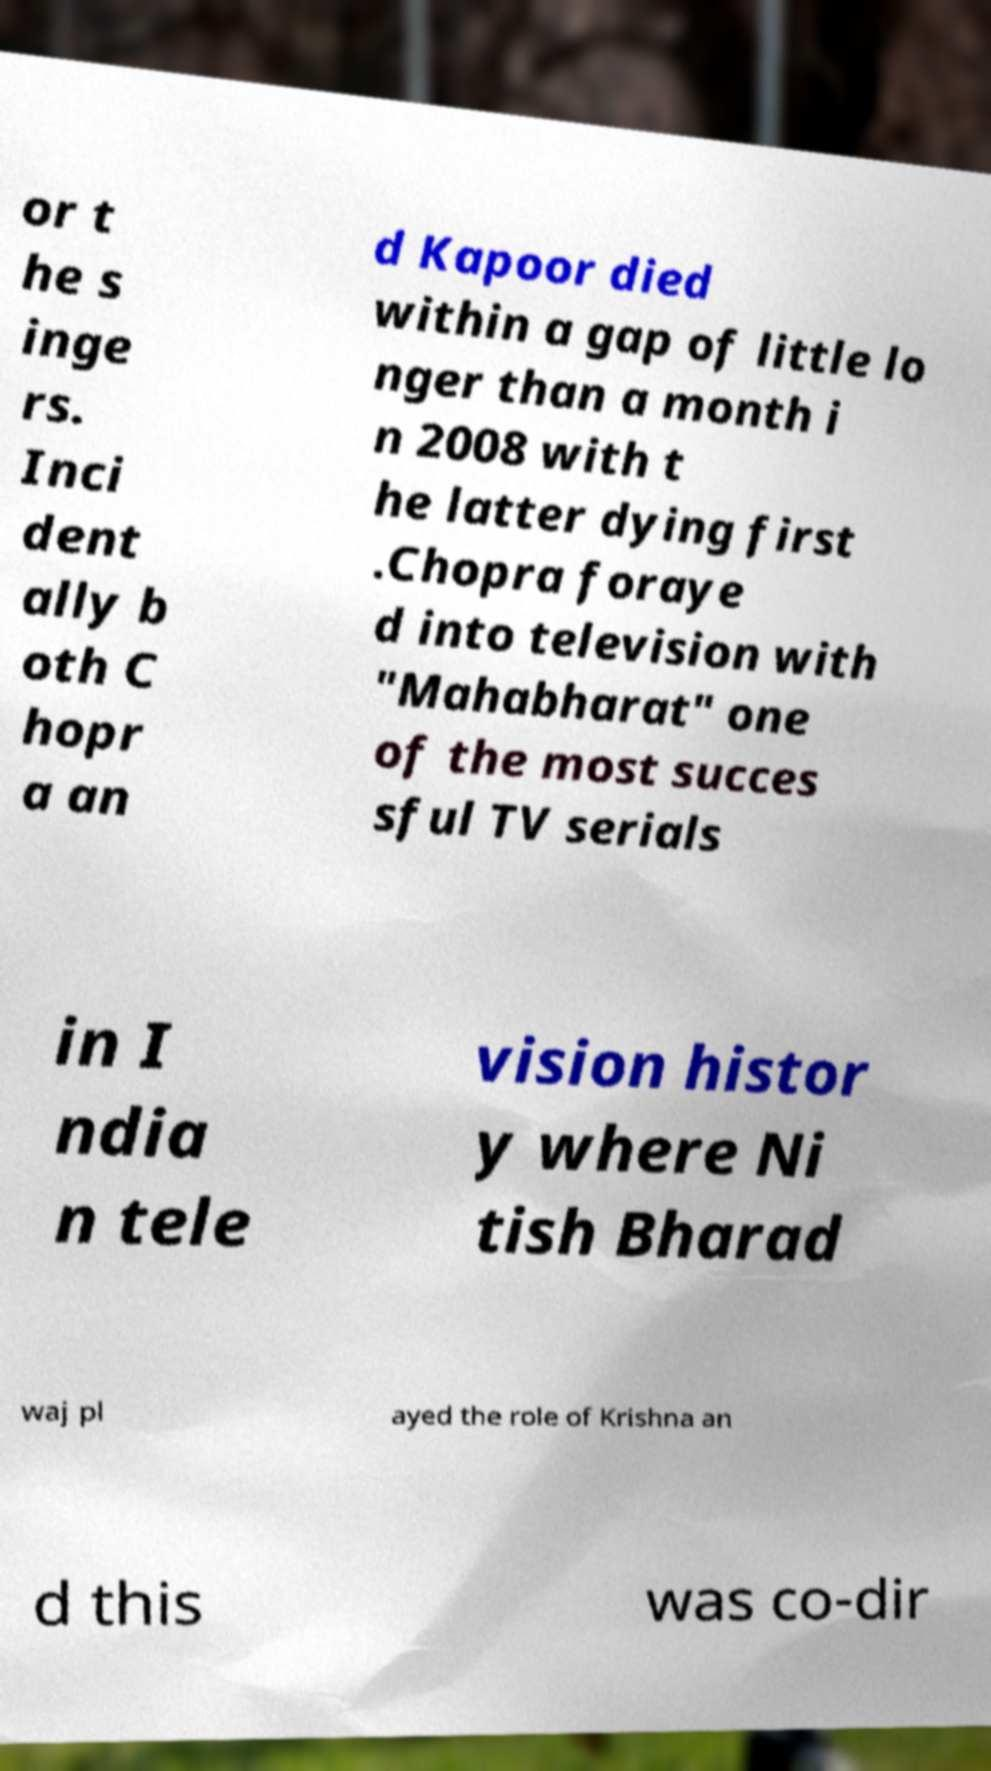Please identify and transcribe the text found in this image. or t he s inge rs. Inci dent ally b oth C hopr a an d Kapoor died within a gap of little lo nger than a month i n 2008 with t he latter dying first .Chopra foraye d into television with "Mahabharat" one of the most succes sful TV serials in I ndia n tele vision histor y where Ni tish Bharad waj pl ayed the role of Krishna an d this was co-dir 